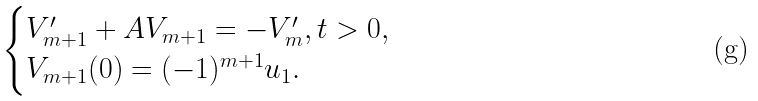<formula> <loc_0><loc_0><loc_500><loc_500>\begin{cases} V _ { m + 1 } ^ { \prime } + A V _ { m + 1 } = - V _ { m } ^ { \prime } , t > 0 , \\ V _ { m + 1 } ( 0 ) = ( - 1 ) ^ { m + 1 } u _ { 1 } . \end{cases}</formula> 